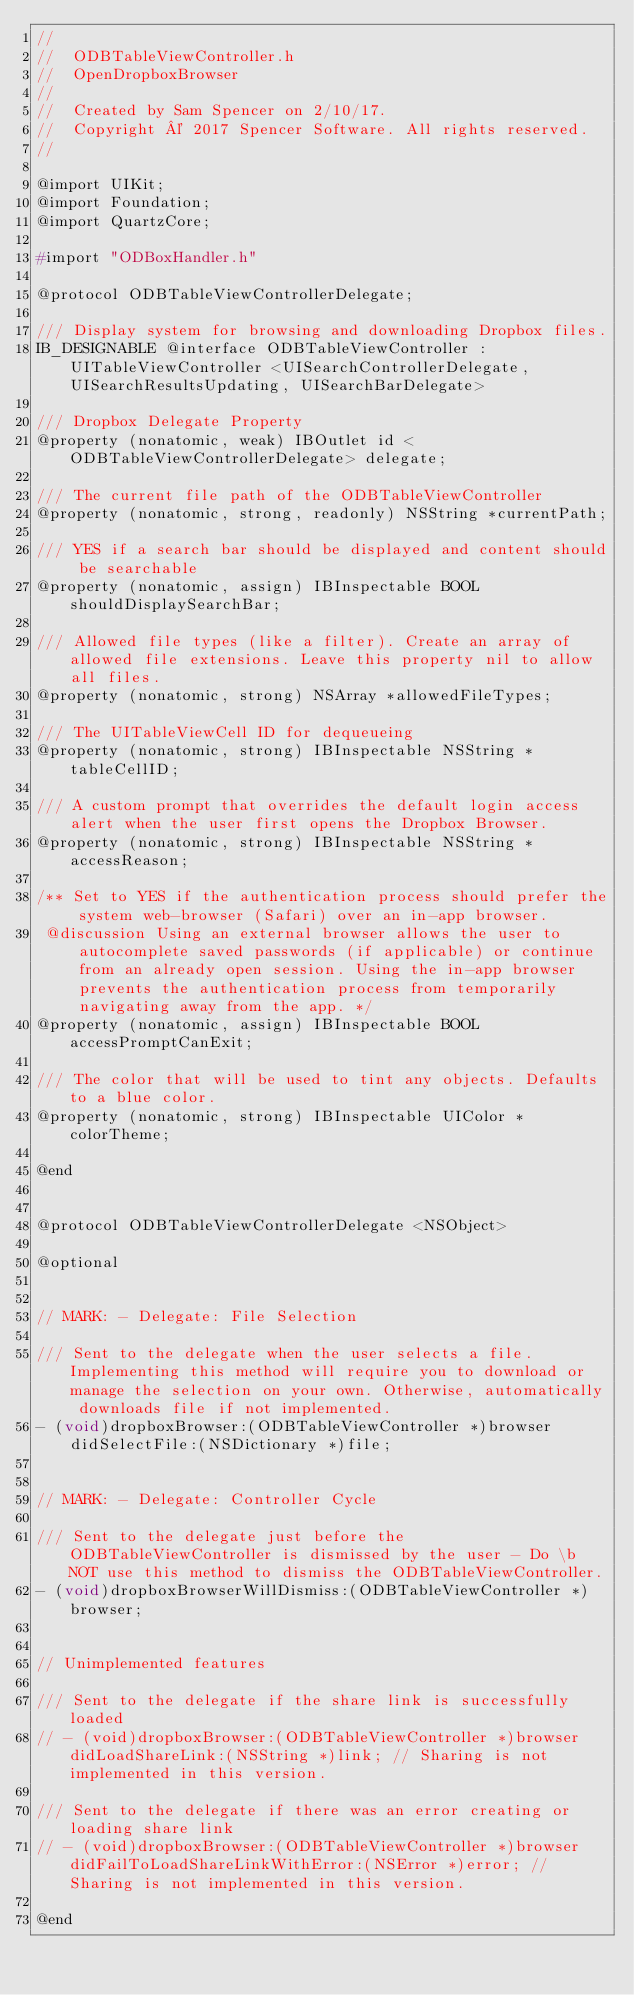<code> <loc_0><loc_0><loc_500><loc_500><_C_>//
//  ODBTableViewController.h
//  OpenDropboxBrowser
//
//  Created by Sam Spencer on 2/10/17.
//  Copyright © 2017 Spencer Software. All rights reserved.
//

@import UIKit;
@import Foundation;
@import QuartzCore;

#import "ODBoxHandler.h"

@protocol ODBTableViewControllerDelegate;

/// Display system for browsing and downloading Dropbox files.
IB_DESIGNABLE @interface ODBTableViewController : UITableViewController <UISearchControllerDelegate, UISearchResultsUpdating, UISearchBarDelegate>

/// Dropbox Delegate Property
@property (nonatomic, weak) IBOutlet id <ODBTableViewControllerDelegate> delegate;

/// The current file path of the ODBTableViewController
@property (nonatomic, strong, readonly) NSString *currentPath;

/// YES if a search bar should be displayed and content should be searchable
@property (nonatomic, assign) IBInspectable BOOL shouldDisplaySearchBar;

/// Allowed file types (like a filter). Create an array of allowed file extensions. Leave this property nil to allow all files.
@property (nonatomic, strong) NSArray *allowedFileTypes;

/// The UITableViewCell ID for dequeueing
@property (nonatomic, strong) IBInspectable NSString *tableCellID;

/// A custom prompt that overrides the default login access alert when the user first opens the Dropbox Browser.
@property (nonatomic, strong) IBInspectable NSString *accessReason;

/** Set to YES if the authentication process should prefer the system web-browser (Safari) over an in-app browser. 
 @discussion Using an external browser allows the user to autocomplete saved passwords (if applicable) or continue from an already open session. Using the in-app browser prevents the authentication process from temporarily navigating away from the app. */
@property (nonatomic, assign) IBInspectable BOOL accessPromptCanExit;

/// The color that will be used to tint any objects. Defaults to a blue color.
@property (nonatomic, strong) IBInspectable UIColor *colorTheme;

@end


@protocol ODBTableViewControllerDelegate <NSObject>

@optional


// MARK: - Delegate: File Selection

/// Sent to the delegate when the user selects a file. Implementing this method will require you to download or manage the selection on your own. Otherwise, automatically downloads file if not implemented.
- (void)dropboxBrowser:(ODBTableViewController *)browser didSelectFile:(NSDictionary *)file;


// MARK: - Delegate: Controller Cycle

/// Sent to the delegate just before the ODBTableViewController is dismissed by the user - Do \b NOT use this method to dismiss the ODBTableViewController.
- (void)dropboxBrowserWillDismiss:(ODBTableViewController *)browser;


// Unimplemented features

/// Sent to the delegate if the share link is successfully loaded
// - (void)dropboxBrowser:(ODBTableViewController *)browser didLoadShareLink:(NSString *)link; // Sharing is not implemented in this version.

/// Sent to the delegate if there was an error creating or loading share link
// - (void)dropboxBrowser:(ODBTableViewController *)browser didFailToLoadShareLinkWithError:(NSError *)error; // Sharing is not implemented in this version.

@end
</code> 